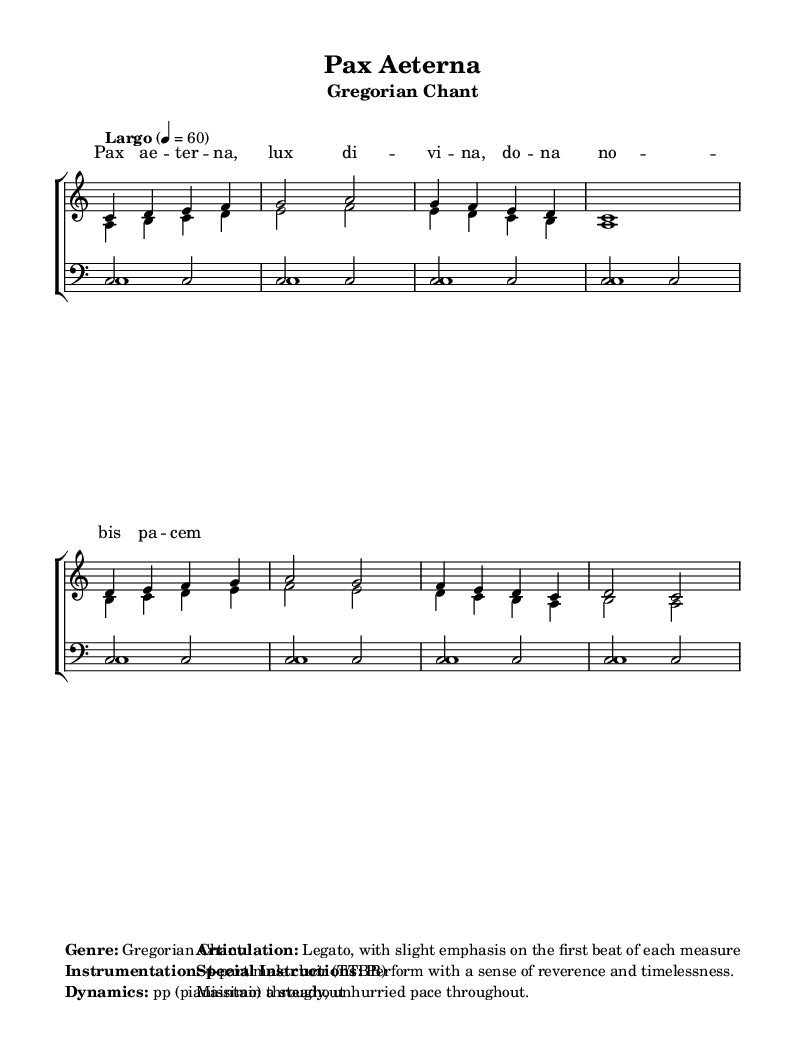What is the key signature of this music? The key signature is C major, which has no sharps or flats.
Answer: C major What is the time signature of this piece? The time signature is 4/4, indicating four beats per measure.
Answer: 4/4 What is the tempo marking for this chant? The tempo marking indicates "Largo," which is a slow tempo.
Answer: Largo How many parts are there in the choir? The choir consists of four parts: two tenors and two basses, forming a TTBB arrangement.
Answer: 4 What is the dynamic marking for this piece? The dynamic marking indicates ‘pp’, which stands for pianissimo, suggesting very soft singing throughout.
Answer: pp What is the main theme or mood conveyed by the lyrics? The lyrics express themes of peace and divinity, contributing to a reverent and serene mood.
Answer: Peace and serenity What kind of articulation is indicated for the performance of this chant? The articulation is legato, which means the notes should be sung smoothly and connected.
Answer: Legato 